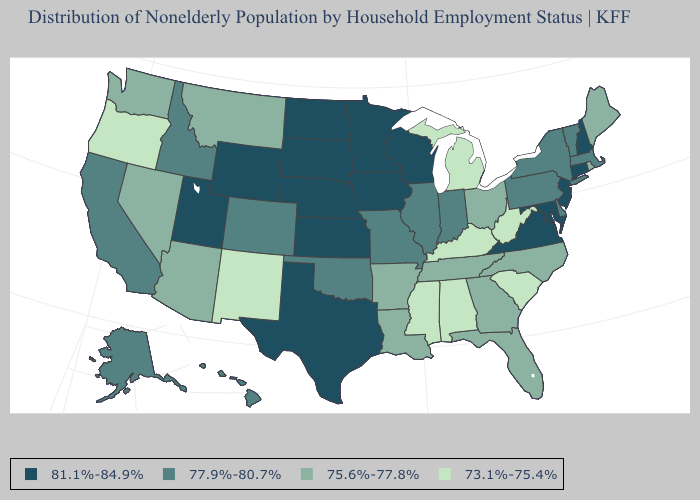What is the value of Arizona?
Give a very brief answer. 75.6%-77.8%. Name the states that have a value in the range 73.1%-75.4%?
Write a very short answer. Alabama, Kentucky, Michigan, Mississippi, New Mexico, Oregon, South Carolina, West Virginia. What is the value of Delaware?
Be succinct. 77.9%-80.7%. Does Alabama have the same value as Wisconsin?
Keep it brief. No. Is the legend a continuous bar?
Answer briefly. No. Does Oregon have the lowest value in the West?
Concise answer only. Yes. Does New Mexico have the lowest value in the USA?
Keep it brief. Yes. What is the value of Idaho?
Write a very short answer. 77.9%-80.7%. Name the states that have a value in the range 73.1%-75.4%?
Be succinct. Alabama, Kentucky, Michigan, Mississippi, New Mexico, Oregon, South Carolina, West Virginia. Name the states that have a value in the range 81.1%-84.9%?
Short answer required. Connecticut, Iowa, Kansas, Maryland, Minnesota, Nebraska, New Hampshire, New Jersey, North Dakota, South Dakota, Texas, Utah, Virginia, Wisconsin, Wyoming. What is the lowest value in states that border New Mexico?
Concise answer only. 75.6%-77.8%. Among the states that border North Dakota , which have the highest value?
Be succinct. Minnesota, South Dakota. Which states have the lowest value in the MidWest?
Give a very brief answer. Michigan. What is the value of Maryland?
Be succinct. 81.1%-84.9%. 